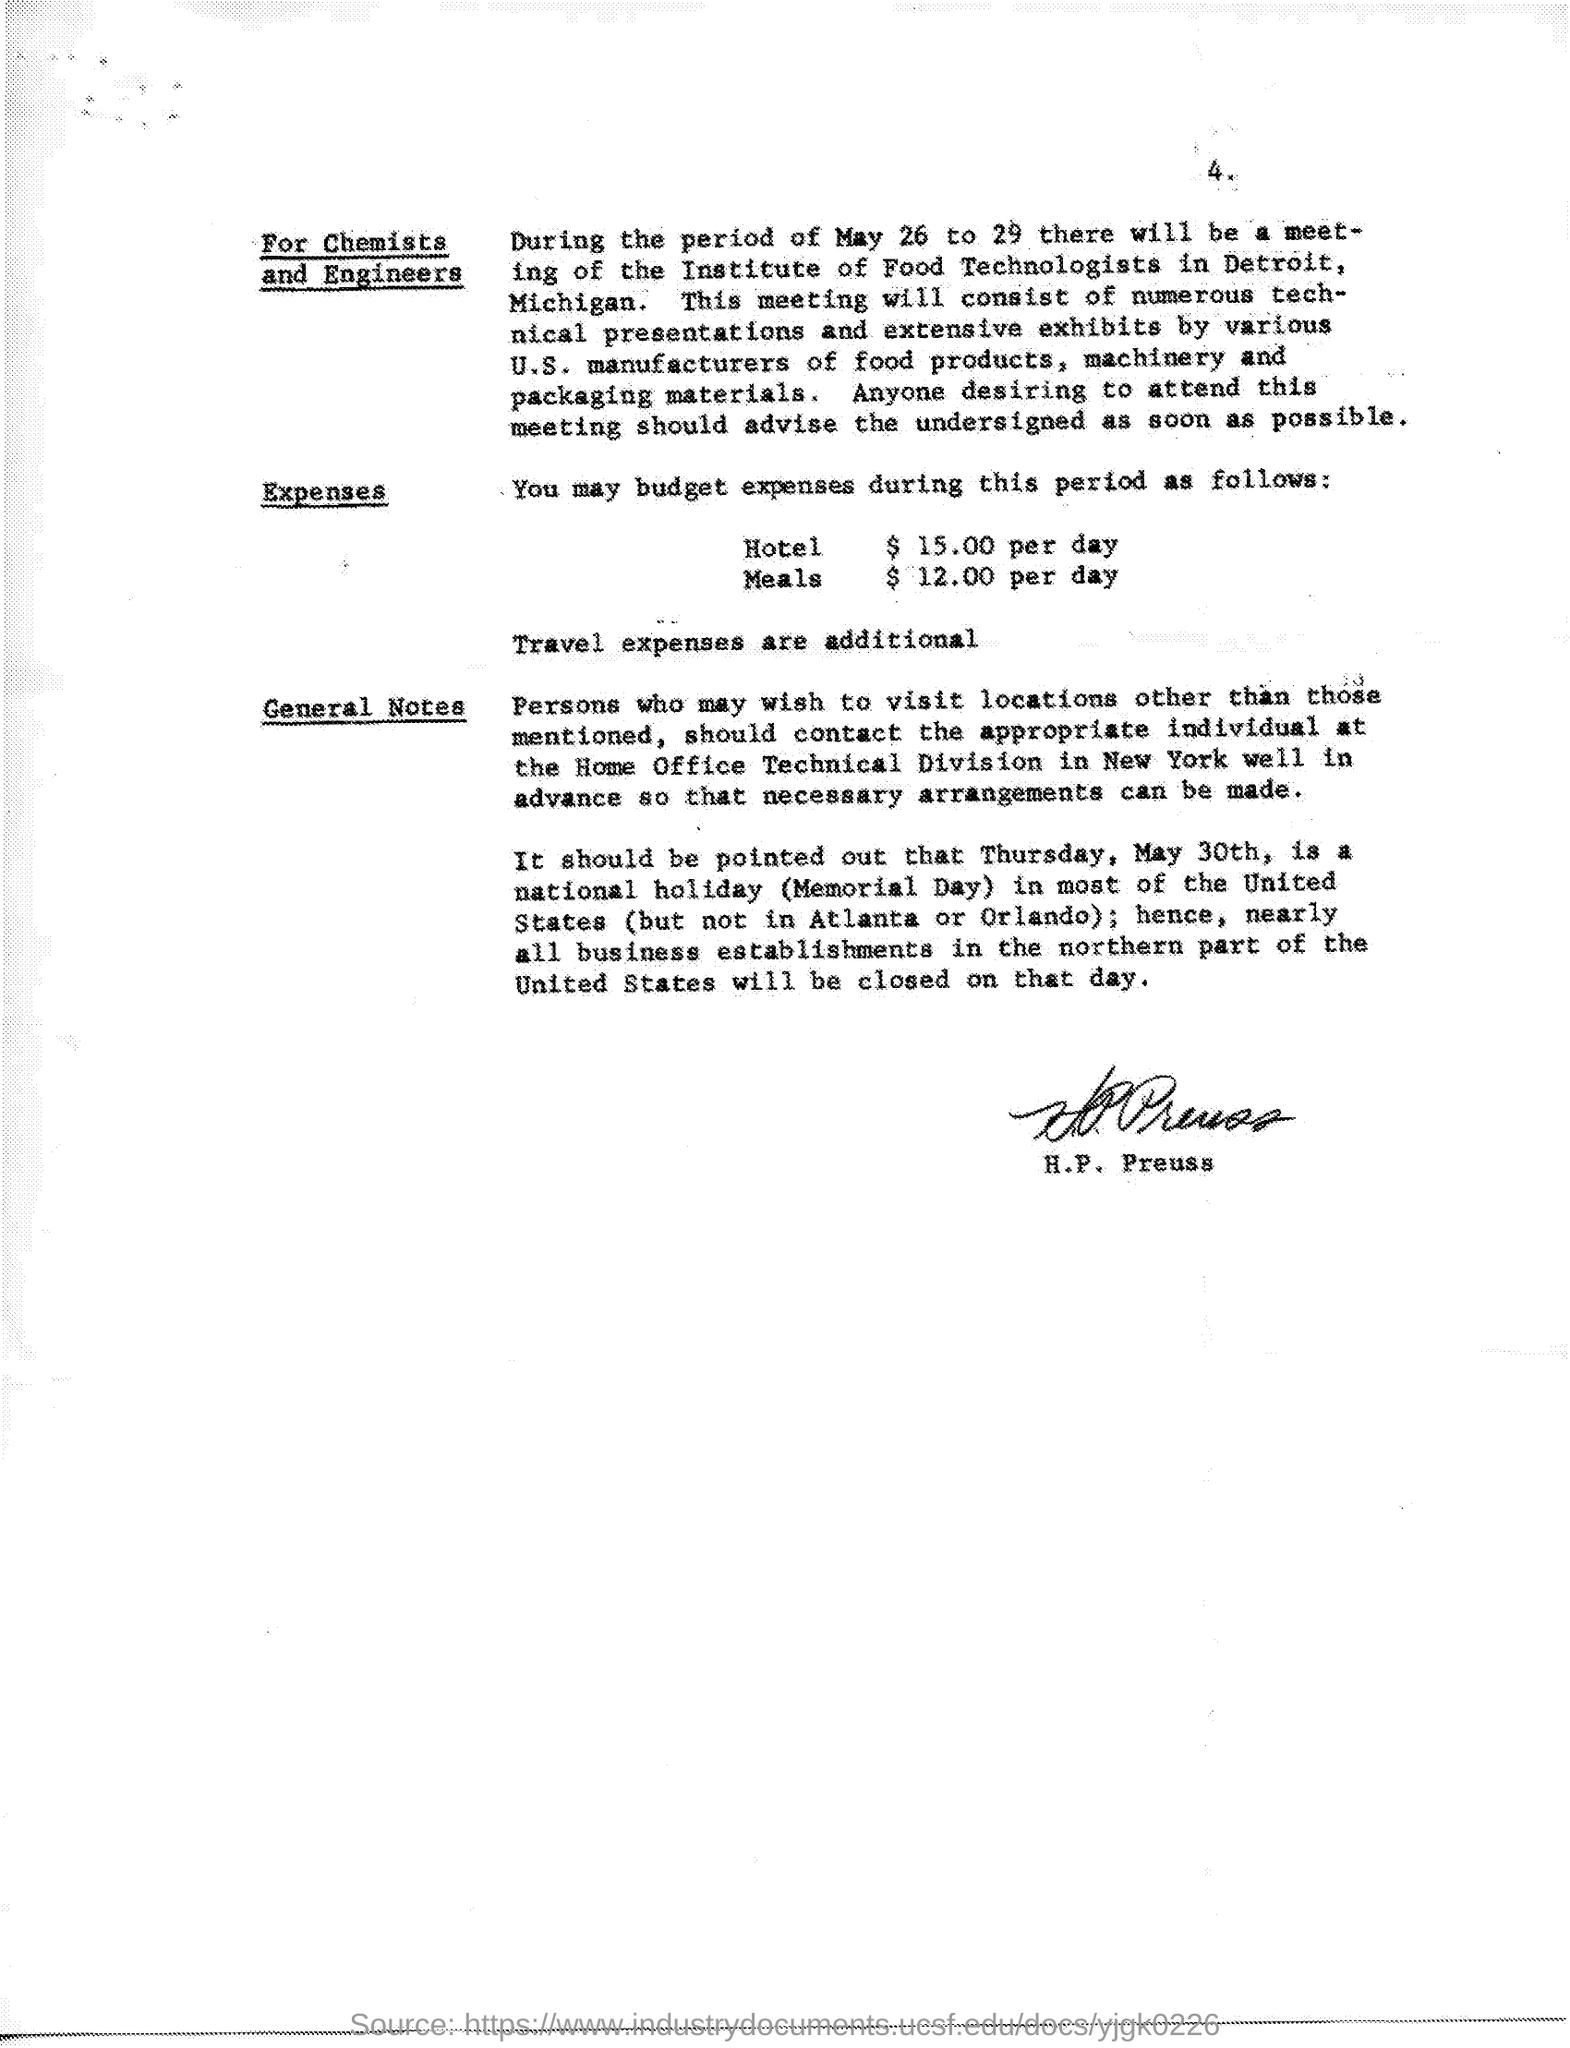Give some essential details in this illustration. The hotel expense is $15.00 per day. The meeting for chemists and engineers is scheduled for May 26 to 29. 